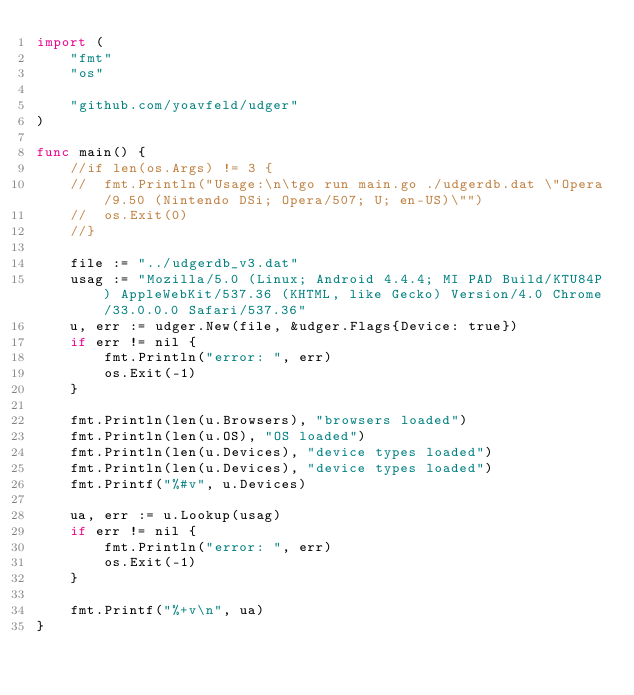<code> <loc_0><loc_0><loc_500><loc_500><_Go_>import (
	"fmt"
	"os"

	"github.com/yoavfeld/udger"
)

func main() {
	//if len(os.Args) != 3 {
	//	fmt.Println("Usage:\n\tgo run main.go ./udgerdb.dat \"Opera/9.50 (Nintendo DSi; Opera/507; U; en-US)\"")
	//	os.Exit(0)
	//}

	file := "../udgerdb_v3.dat"
	usag := "Mozilla/5.0 (Linux; Android 4.4.4; MI PAD Build/KTU84P) AppleWebKit/537.36 (KHTML, like Gecko) Version/4.0 Chrome/33.0.0.0 Safari/537.36"
	u, err := udger.New(file, &udger.Flags{Device: true})
	if err != nil {
		fmt.Println("error: ", err)
		os.Exit(-1)
	}

	fmt.Println(len(u.Browsers), "browsers loaded")
	fmt.Println(len(u.OS), "OS loaded")
	fmt.Println(len(u.Devices), "device types loaded")
	fmt.Println(len(u.Devices), "device types loaded")
	fmt.Printf("%#v", u.Devices)

	ua, err := u.Lookup(usag)
	if err != nil {
		fmt.Println("error: ", err)
		os.Exit(-1)
	}

	fmt.Printf("%+v\n", ua)
}
</code> 